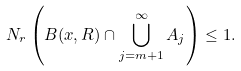<formula> <loc_0><loc_0><loc_500><loc_500>N _ { r } \left ( B ( x , R ) \cap \bigcup _ { j = m + 1 } ^ { \infty } A _ { j } \right ) \leq 1 .</formula> 